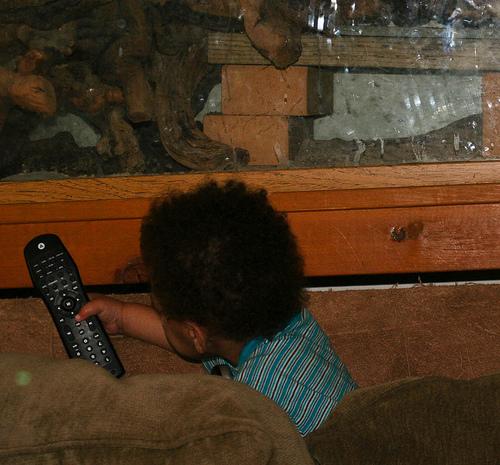What will the child want to do with the remote?
Concise answer only. Play with it. What color is the couch?
Quick response, please. Brown. Is there a teenager in the photo?
Give a very brief answer. No. 